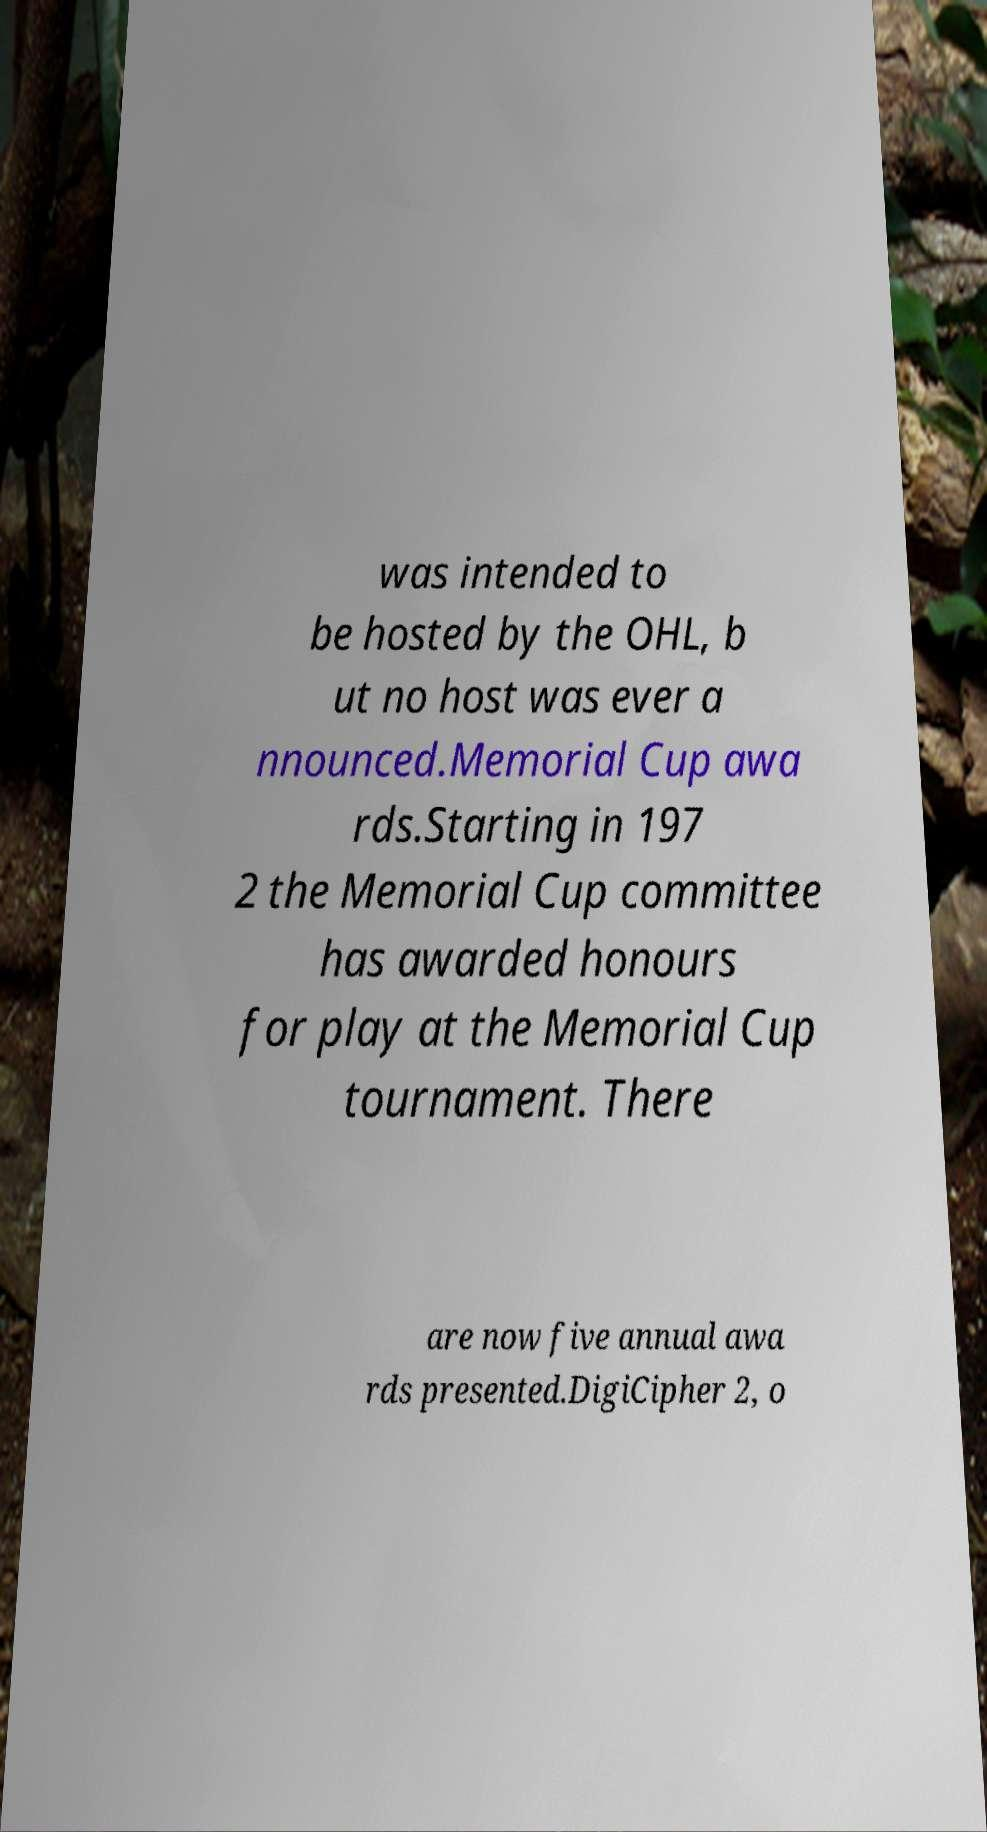Please read and relay the text visible in this image. What does it say? was intended to be hosted by the OHL, b ut no host was ever a nnounced.Memorial Cup awa rds.Starting in 197 2 the Memorial Cup committee has awarded honours for play at the Memorial Cup tournament. There are now five annual awa rds presented.DigiCipher 2, o 